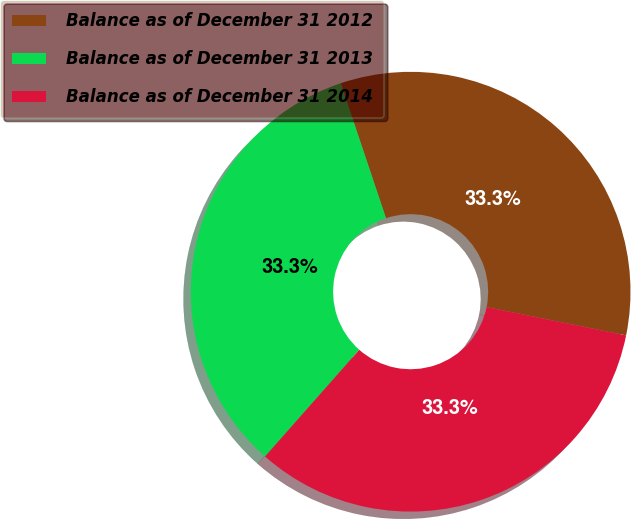<chart> <loc_0><loc_0><loc_500><loc_500><pie_chart><fcel>Balance as of December 31 2012<fcel>Balance as of December 31 2013<fcel>Balance as of December 31 2014<nl><fcel>33.33%<fcel>33.33%<fcel>33.33%<nl></chart> 